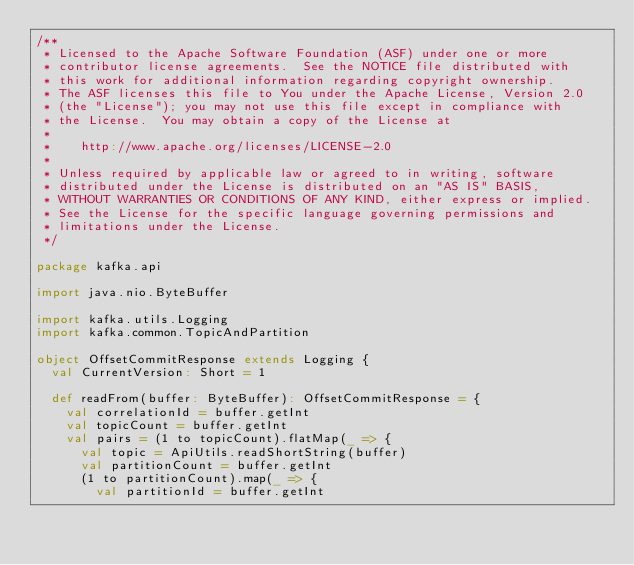<code> <loc_0><loc_0><loc_500><loc_500><_Scala_>/**
 * Licensed to the Apache Software Foundation (ASF) under one or more
 * contributor license agreements.  See the NOTICE file distributed with
 * this work for additional information regarding copyright ownership.
 * The ASF licenses this file to You under the Apache License, Version 2.0
 * (the "License"); you may not use this file except in compliance with
 * the License.  You may obtain a copy of the License at
 * 
 *    http://www.apache.org/licenses/LICENSE-2.0
 *
 * Unless required by applicable law or agreed to in writing, software
 * distributed under the License is distributed on an "AS IS" BASIS,
 * WITHOUT WARRANTIES OR CONDITIONS OF ANY KIND, either express or implied.
 * See the License for the specific language governing permissions and
 * limitations under the License.
 */

package kafka.api

import java.nio.ByteBuffer

import kafka.utils.Logging
import kafka.common.TopicAndPartition

object OffsetCommitResponse extends Logging {
  val CurrentVersion: Short = 1

  def readFrom(buffer: ByteBuffer): OffsetCommitResponse = {
    val correlationId = buffer.getInt
    val topicCount = buffer.getInt
    val pairs = (1 to topicCount).flatMap(_ => {
      val topic = ApiUtils.readShortString(buffer)
      val partitionCount = buffer.getInt
      (1 to partitionCount).map(_ => {
        val partitionId = buffer.getInt</code> 